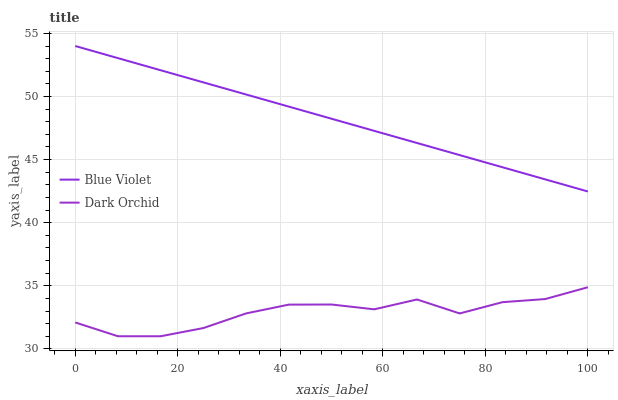Does Dark Orchid have the minimum area under the curve?
Answer yes or no. Yes. Does Blue Violet have the maximum area under the curve?
Answer yes or no. Yes. Does Blue Violet have the minimum area under the curve?
Answer yes or no. No. Is Blue Violet the smoothest?
Answer yes or no. Yes. Is Dark Orchid the roughest?
Answer yes or no. Yes. Is Blue Violet the roughest?
Answer yes or no. No. Does Dark Orchid have the lowest value?
Answer yes or no. Yes. Does Blue Violet have the lowest value?
Answer yes or no. No. Does Blue Violet have the highest value?
Answer yes or no. Yes. Is Dark Orchid less than Blue Violet?
Answer yes or no. Yes. Is Blue Violet greater than Dark Orchid?
Answer yes or no. Yes. Does Dark Orchid intersect Blue Violet?
Answer yes or no. No. 